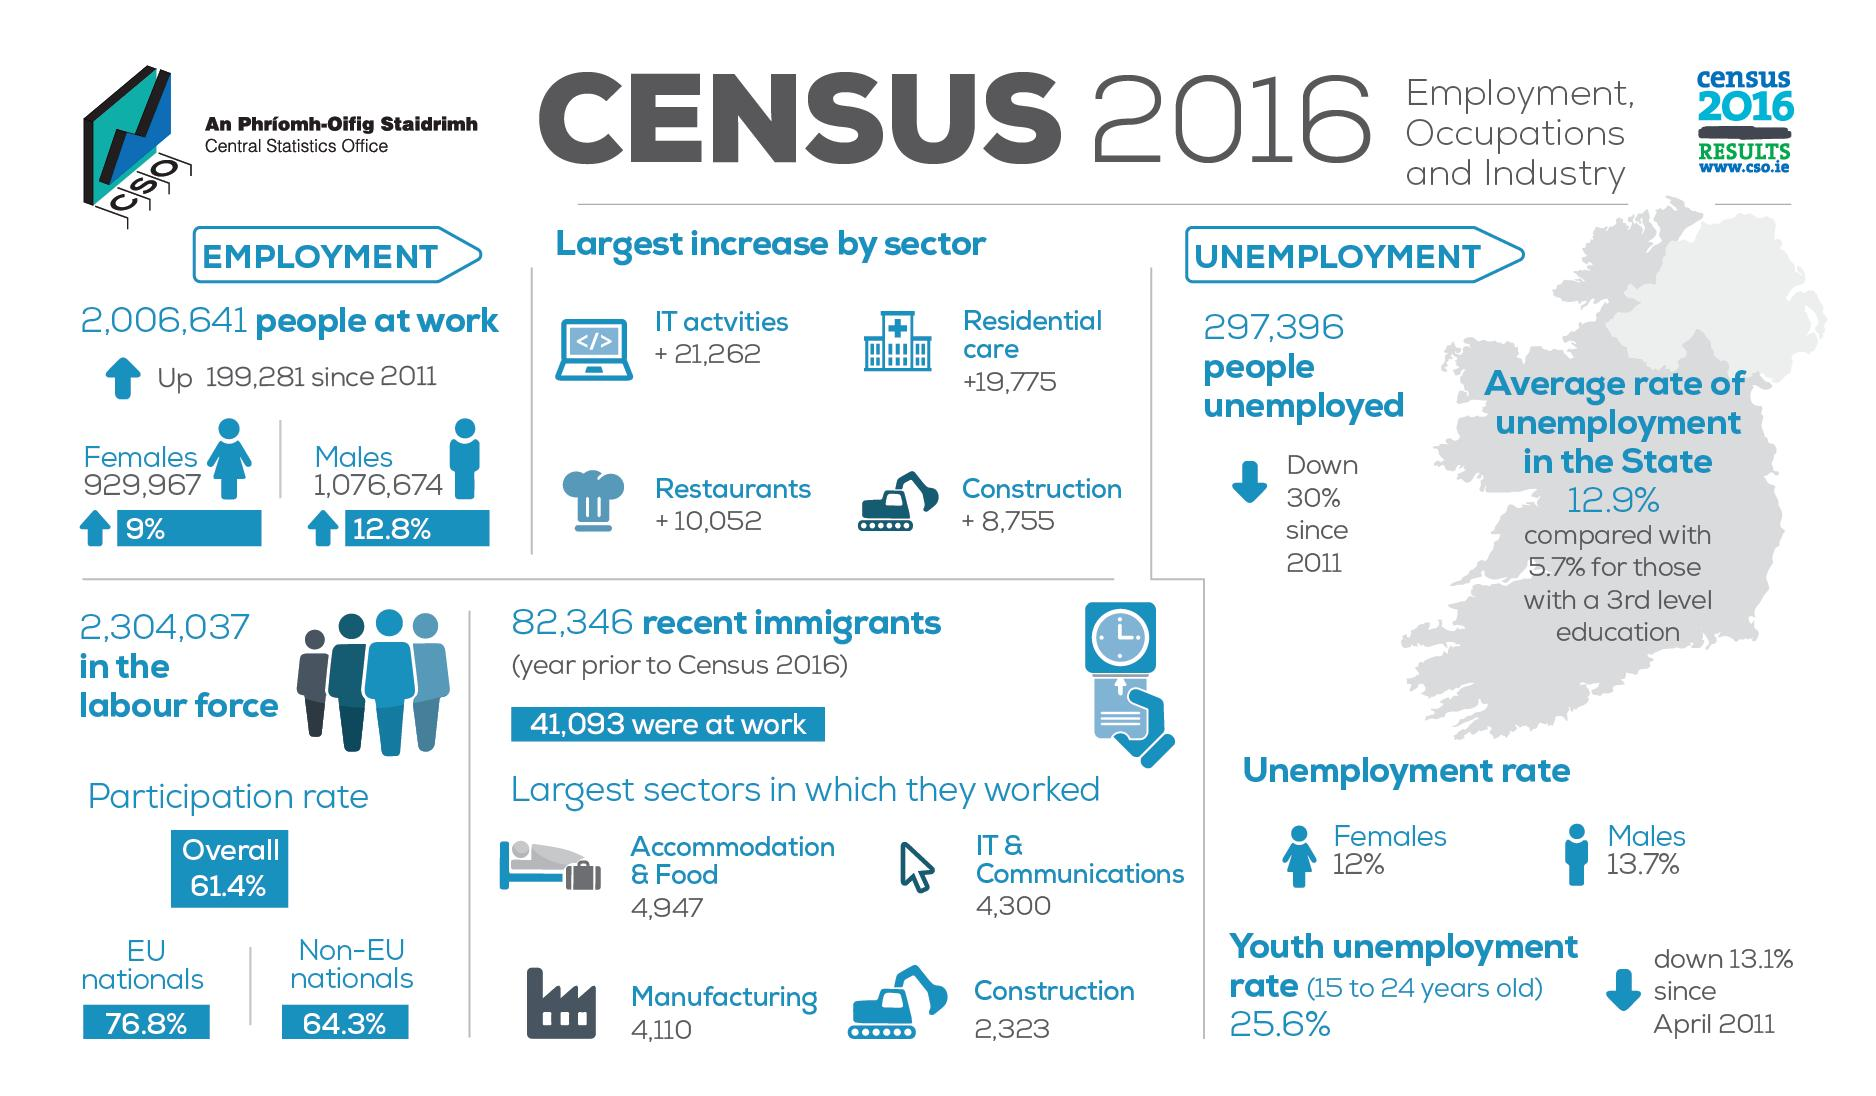Point out several critical features in this image. According to the CSO census in 2016, the number of residents in residential care in Ireland increased by 19,775. In the 2016 CSO census, a total of 4,110 immigrants were found to have worked in the manufacturing industry in Ireland. According to the CSO census in 2016, there were 297,396 people unemployed in Ireland. According to the CSO census in 2016, 12% of the unemployed population in Ireland are female. According to the CSO census in 2016, the percentage increase in male workers in Ireland was 12.8%. 